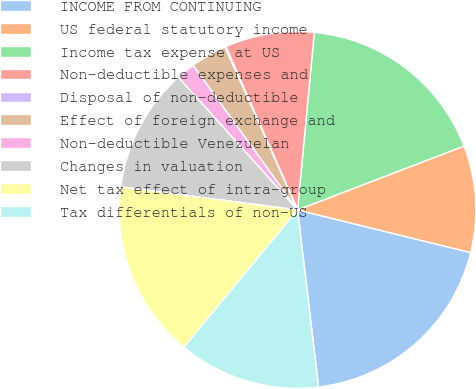Convert chart. <chart><loc_0><loc_0><loc_500><loc_500><pie_chart><fcel>INCOME FROM CONTINUING<fcel>US federal statutory income<fcel>Income tax expense at US<fcel>Non-deductible expenses and<fcel>Disposal of non-deductible<fcel>Effect of foreign exchange and<fcel>Non-deductible Venezuelan<fcel>Changes in valuation<fcel>Net tax effect of intra-group<fcel>Tax differentials of non-US<nl><fcel>19.27%<fcel>9.68%<fcel>17.67%<fcel>8.08%<fcel>0.09%<fcel>3.29%<fcel>1.69%<fcel>11.28%<fcel>16.07%<fcel>12.88%<nl></chart> 